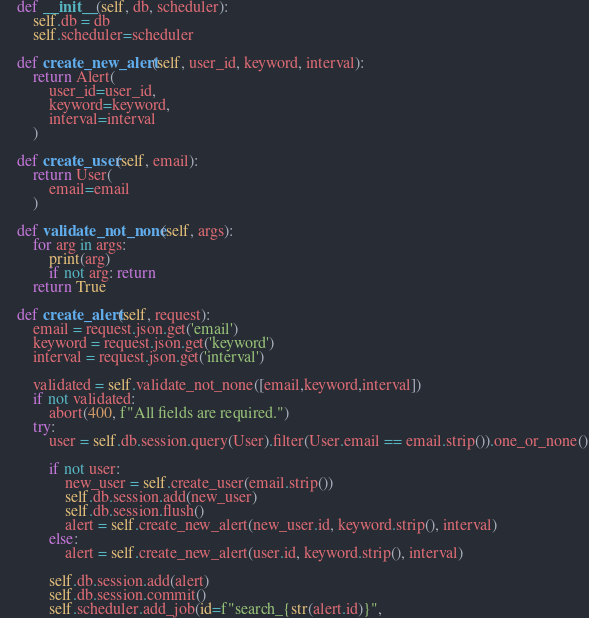Convert code to text. <code><loc_0><loc_0><loc_500><loc_500><_Python_>
    def __init__(self, db, scheduler):
        self.db = db
        self.scheduler=scheduler

    def create_new_alert(self, user_id, keyword, interval):
        return Alert(
            user_id=user_id,
            keyword=keyword,
            interval=interval
        )

    def create_user(self, email):
        return User(
            email=email
        )

    def validate_not_none(self, args):
        for arg in args:
            print(arg)
            if not arg: return        
        return True

    def create_alert(self, request):
        email = request.json.get('email')
        keyword = request.json.get('keyword')
        interval = request.json.get('interval')

        validated = self.validate_not_none([email,keyword,interval])
        if not validated:
            abort(400, f"All fields are required.")
        try:
            user = self.db.session.query(User).filter(User.email == email.strip()).one_or_none()

            if not user:
                new_user = self.create_user(email.strip())
                self.db.session.add(new_user)
                self.db.session.flush()
                alert = self.create_new_alert(new_user.id, keyword.strip(), interval)
            else:
                alert = self.create_new_alert(user.id, keyword.strip(), interval)

            self.db.session.add(alert)
            self.db.session.commit()
            self.scheduler.add_job(id=f"search_{str(alert.id)}",</code> 